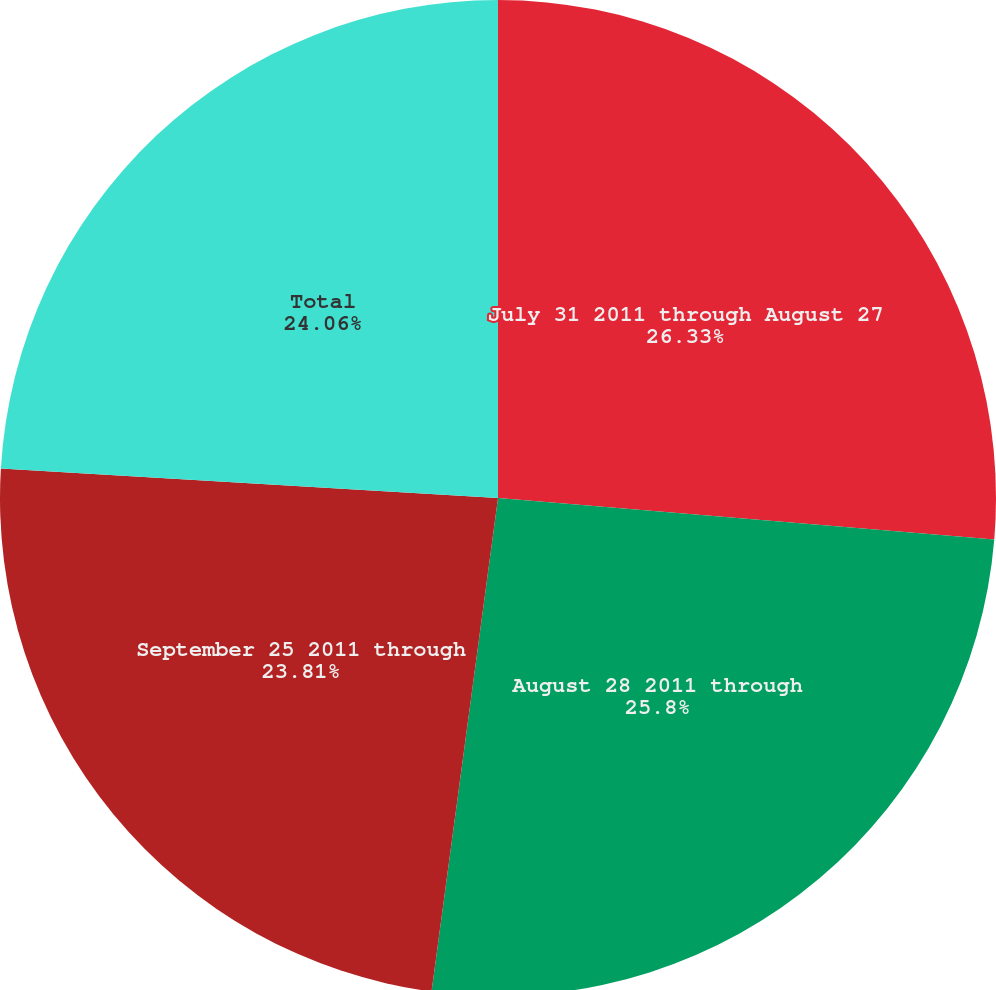Convert chart to OTSL. <chart><loc_0><loc_0><loc_500><loc_500><pie_chart><fcel>July 31 2011 through August 27<fcel>August 28 2011 through<fcel>September 25 2011 through<fcel>Total<nl><fcel>26.33%<fcel>25.8%<fcel>23.81%<fcel>24.06%<nl></chart> 